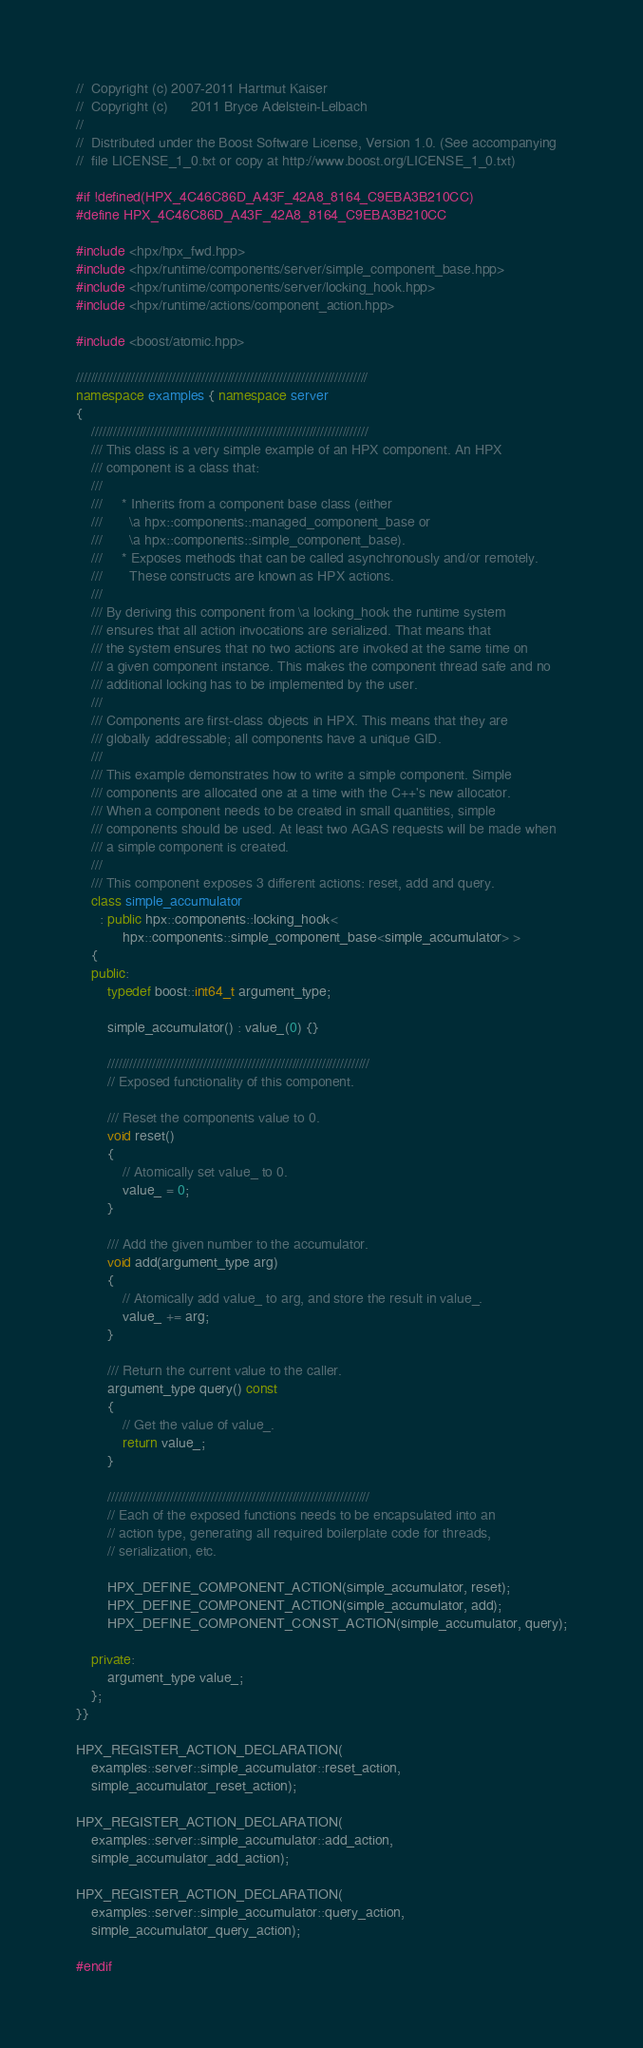Convert code to text. <code><loc_0><loc_0><loc_500><loc_500><_C++_>//  Copyright (c) 2007-2011 Hartmut Kaiser
//  Copyright (c)      2011 Bryce Adelstein-Lelbach
//
//  Distributed under the Boost Software License, Version 1.0. (See accompanying
//  file LICENSE_1_0.txt or copy at http://www.boost.org/LICENSE_1_0.txt)

#if !defined(HPX_4C46C86D_A43F_42A8_8164_C9EBA3B210CC)
#define HPX_4C46C86D_A43F_42A8_8164_C9EBA3B210CC

#include <hpx/hpx_fwd.hpp>
#include <hpx/runtime/components/server/simple_component_base.hpp>
#include <hpx/runtime/components/server/locking_hook.hpp>
#include <hpx/runtime/actions/component_action.hpp>

#include <boost/atomic.hpp>

///////////////////////////////////////////////////////////////////////////////
namespace examples { namespace server
{
    ///////////////////////////////////////////////////////////////////////////
    /// This class is a very simple example of an HPX component. An HPX
    /// component is a class that:
    ///
    ///     * Inherits from a component base class (either
    ///       \a hpx::components::managed_component_base or
    ///       \a hpx::components::simple_component_base).
    ///     * Exposes methods that can be called asynchronously and/or remotely.
    ///       These constructs are known as HPX actions.
    ///
    /// By deriving this component from \a locking_hook the runtime system 
    /// ensures that all action invocations are serialized. That means that 
    /// the system ensures that no two actions are invoked at the same time on
    /// a given component instance. This makes the component thread safe and no
    /// additional locking has to be implemented by the user.
    ///
    /// Components are first-class objects in HPX. This means that they are
    /// globally addressable; all components have a unique GID.
    ///
    /// This example demonstrates how to write a simple component. Simple
    /// components are allocated one at a time with the C++'s new allocator.
    /// When a component needs to be created in small quantities, simple
    /// components should be used. At least two AGAS requests will be made when
    /// a simple component is created.
    ///
    /// This component exposes 3 different actions: reset, add and query.
    class simple_accumulator
      : public hpx::components::locking_hook<
            hpx::components::simple_component_base<simple_accumulator> >
    {
    public:
        typedef boost::int64_t argument_type;

        simple_accumulator() : value_(0) {}

        ///////////////////////////////////////////////////////////////////////
        // Exposed functionality of this component.

        /// Reset the components value to 0.
        void reset()
        {
            // Atomically set value_ to 0.
            value_ = 0;
        }

        /// Add the given number to the accumulator.
        void add(argument_type arg)
        {
            // Atomically add value_ to arg, and store the result in value_.
            value_ += arg;
        }

        /// Return the current value to the caller.
        argument_type query() const
        {
            // Get the value of value_.
            return value_;
        }

        ///////////////////////////////////////////////////////////////////////
        // Each of the exposed functions needs to be encapsulated into an
        // action type, generating all required boilerplate code for threads,
        // serialization, etc.

        HPX_DEFINE_COMPONENT_ACTION(simple_accumulator, reset);
        HPX_DEFINE_COMPONENT_ACTION(simple_accumulator, add);
        HPX_DEFINE_COMPONENT_CONST_ACTION(simple_accumulator, query);

    private:
        argument_type value_;
    };
}}

HPX_REGISTER_ACTION_DECLARATION(
    examples::server::simple_accumulator::reset_action,
    simple_accumulator_reset_action);

HPX_REGISTER_ACTION_DECLARATION(
    examples::server::simple_accumulator::add_action,
    simple_accumulator_add_action);

HPX_REGISTER_ACTION_DECLARATION(
    examples::server::simple_accumulator::query_action,
    simple_accumulator_query_action);

#endif

</code> 